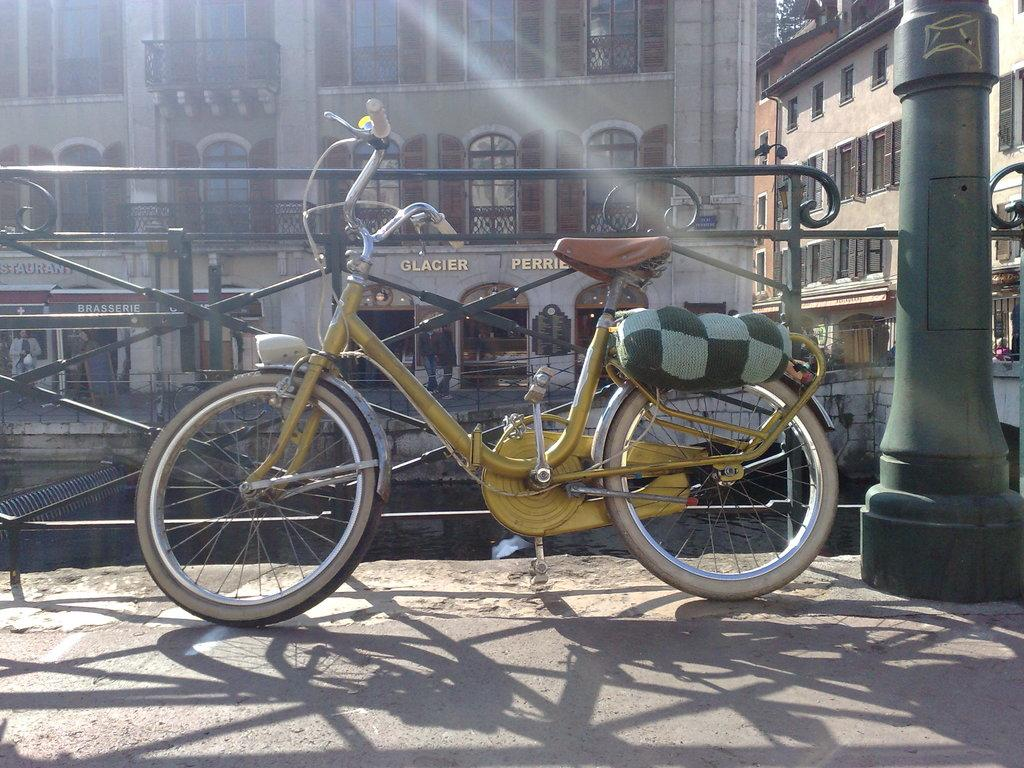What type of structures can be seen in the image? There are buildings in the image. What is written or displayed on a wall in the image? There is text on a wall in the image. What object can be used for displaying information or announcements? There is a board in the image. Can you describe the people present in the image? There are people standing in the image. What mode of transportation is visible in the image? There is a bicycle in the image. What is located on the right side of the image? There is a pole on the right side of the image. What type of vessel is being used by the father in the image? There is no father or vessel present in the image. What color are the lips of the person standing in the image? There is no mention of lips or a specific person's features in the image. 